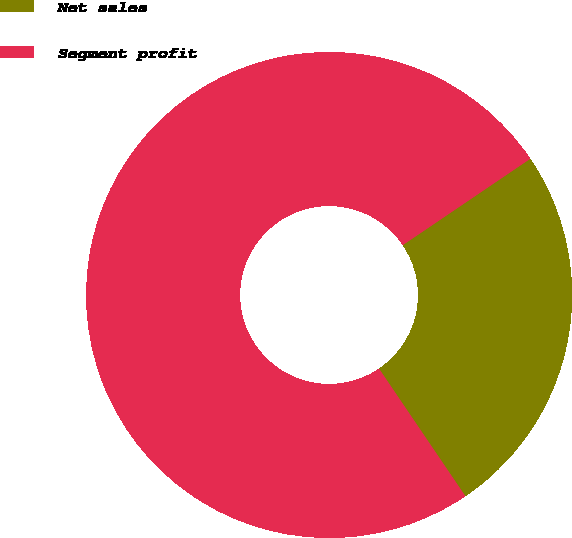Convert chart to OTSL. <chart><loc_0><loc_0><loc_500><loc_500><pie_chart><fcel>Net sales<fcel>Segment profit<nl><fcel>25.0%<fcel>75.0%<nl></chart> 